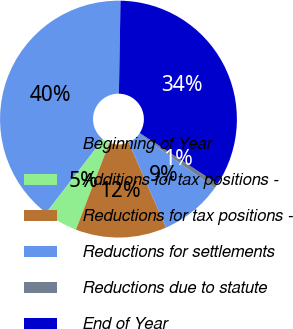Convert chart to OTSL. <chart><loc_0><loc_0><loc_500><loc_500><pie_chart><fcel>Beginning of Year<fcel>Additions for tax positions -<fcel>Reductions for tax positions -<fcel>Reductions for settlements<fcel>Reductions due to statute<fcel>End of Year<nl><fcel>39.82%<fcel>4.61%<fcel>12.43%<fcel>8.52%<fcel>0.69%<fcel>33.93%<nl></chart> 